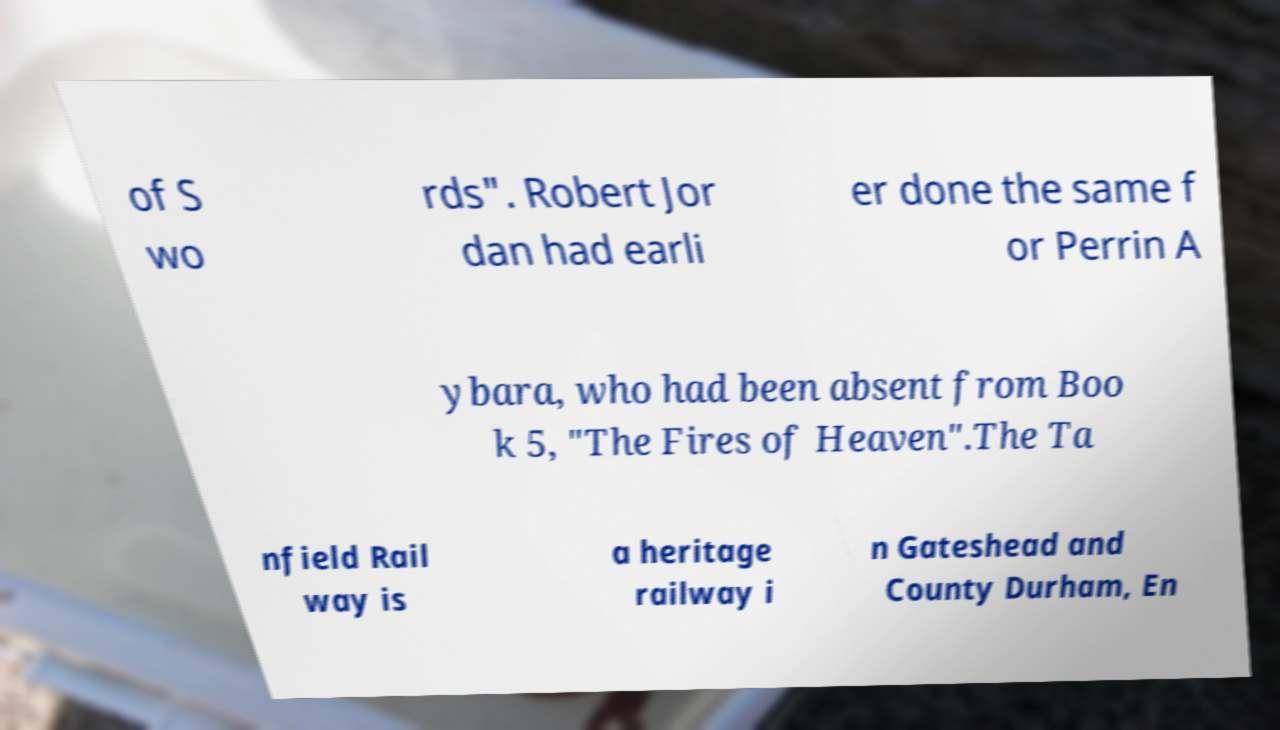There's text embedded in this image that I need extracted. Can you transcribe it verbatim? of S wo rds". Robert Jor dan had earli er done the same f or Perrin A ybara, who had been absent from Boo k 5, "The Fires of Heaven".The Ta nfield Rail way is a heritage railway i n Gateshead and County Durham, En 